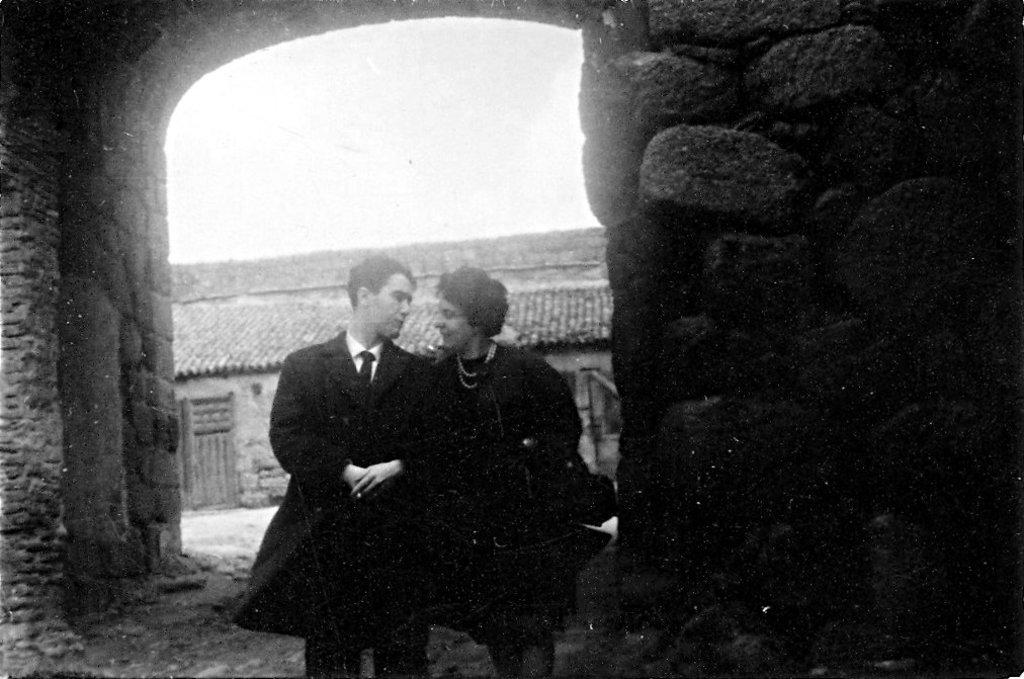Who are the people in the image? There is a man and a woman in the image. What are the man and woman doing in the image? The man and woman are standing. What can be seen in the background of the image? There is a house visible in the background of the image. What trick is the man performing in the image? There is no trick being performed in the image; the man and woman are simply standing. 